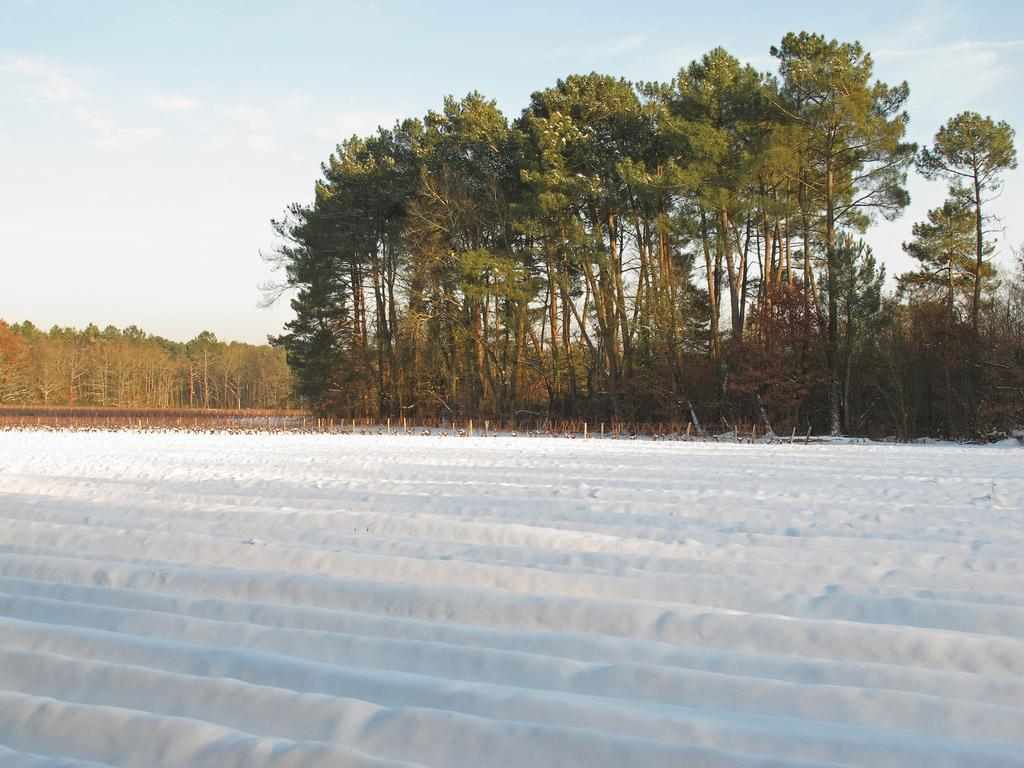What is the primary element covering the ground in the image? The image contains snow, which is covering the ground. What can be seen in the background of the image? There are trees in the background of the image. What part of the natural environment is visible in the image? The sky is visible in the background of the image. What type of oatmeal is being served to the person in the image? There is no person present in the image, and therefore no oatmeal being served. 